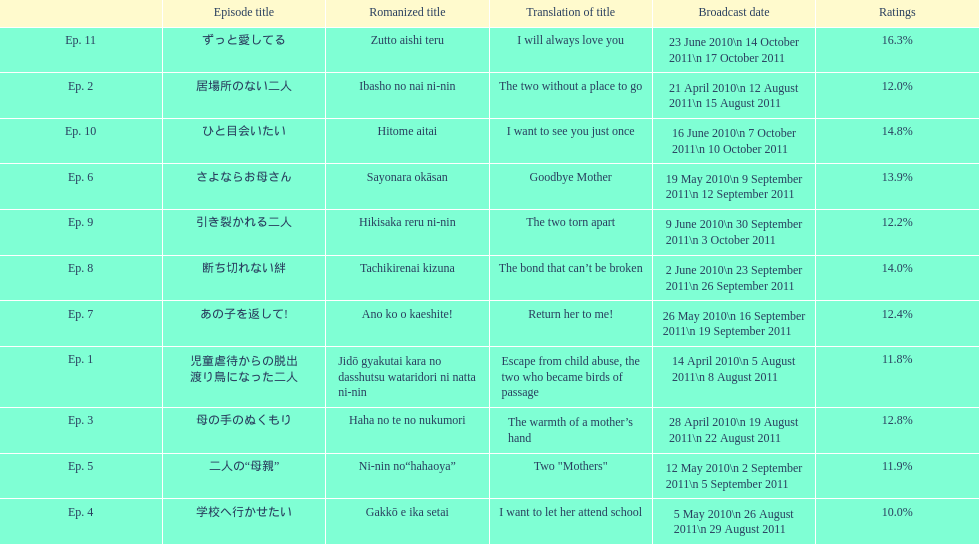How many episodes were broadcast in april 2010 in japan? 3. 